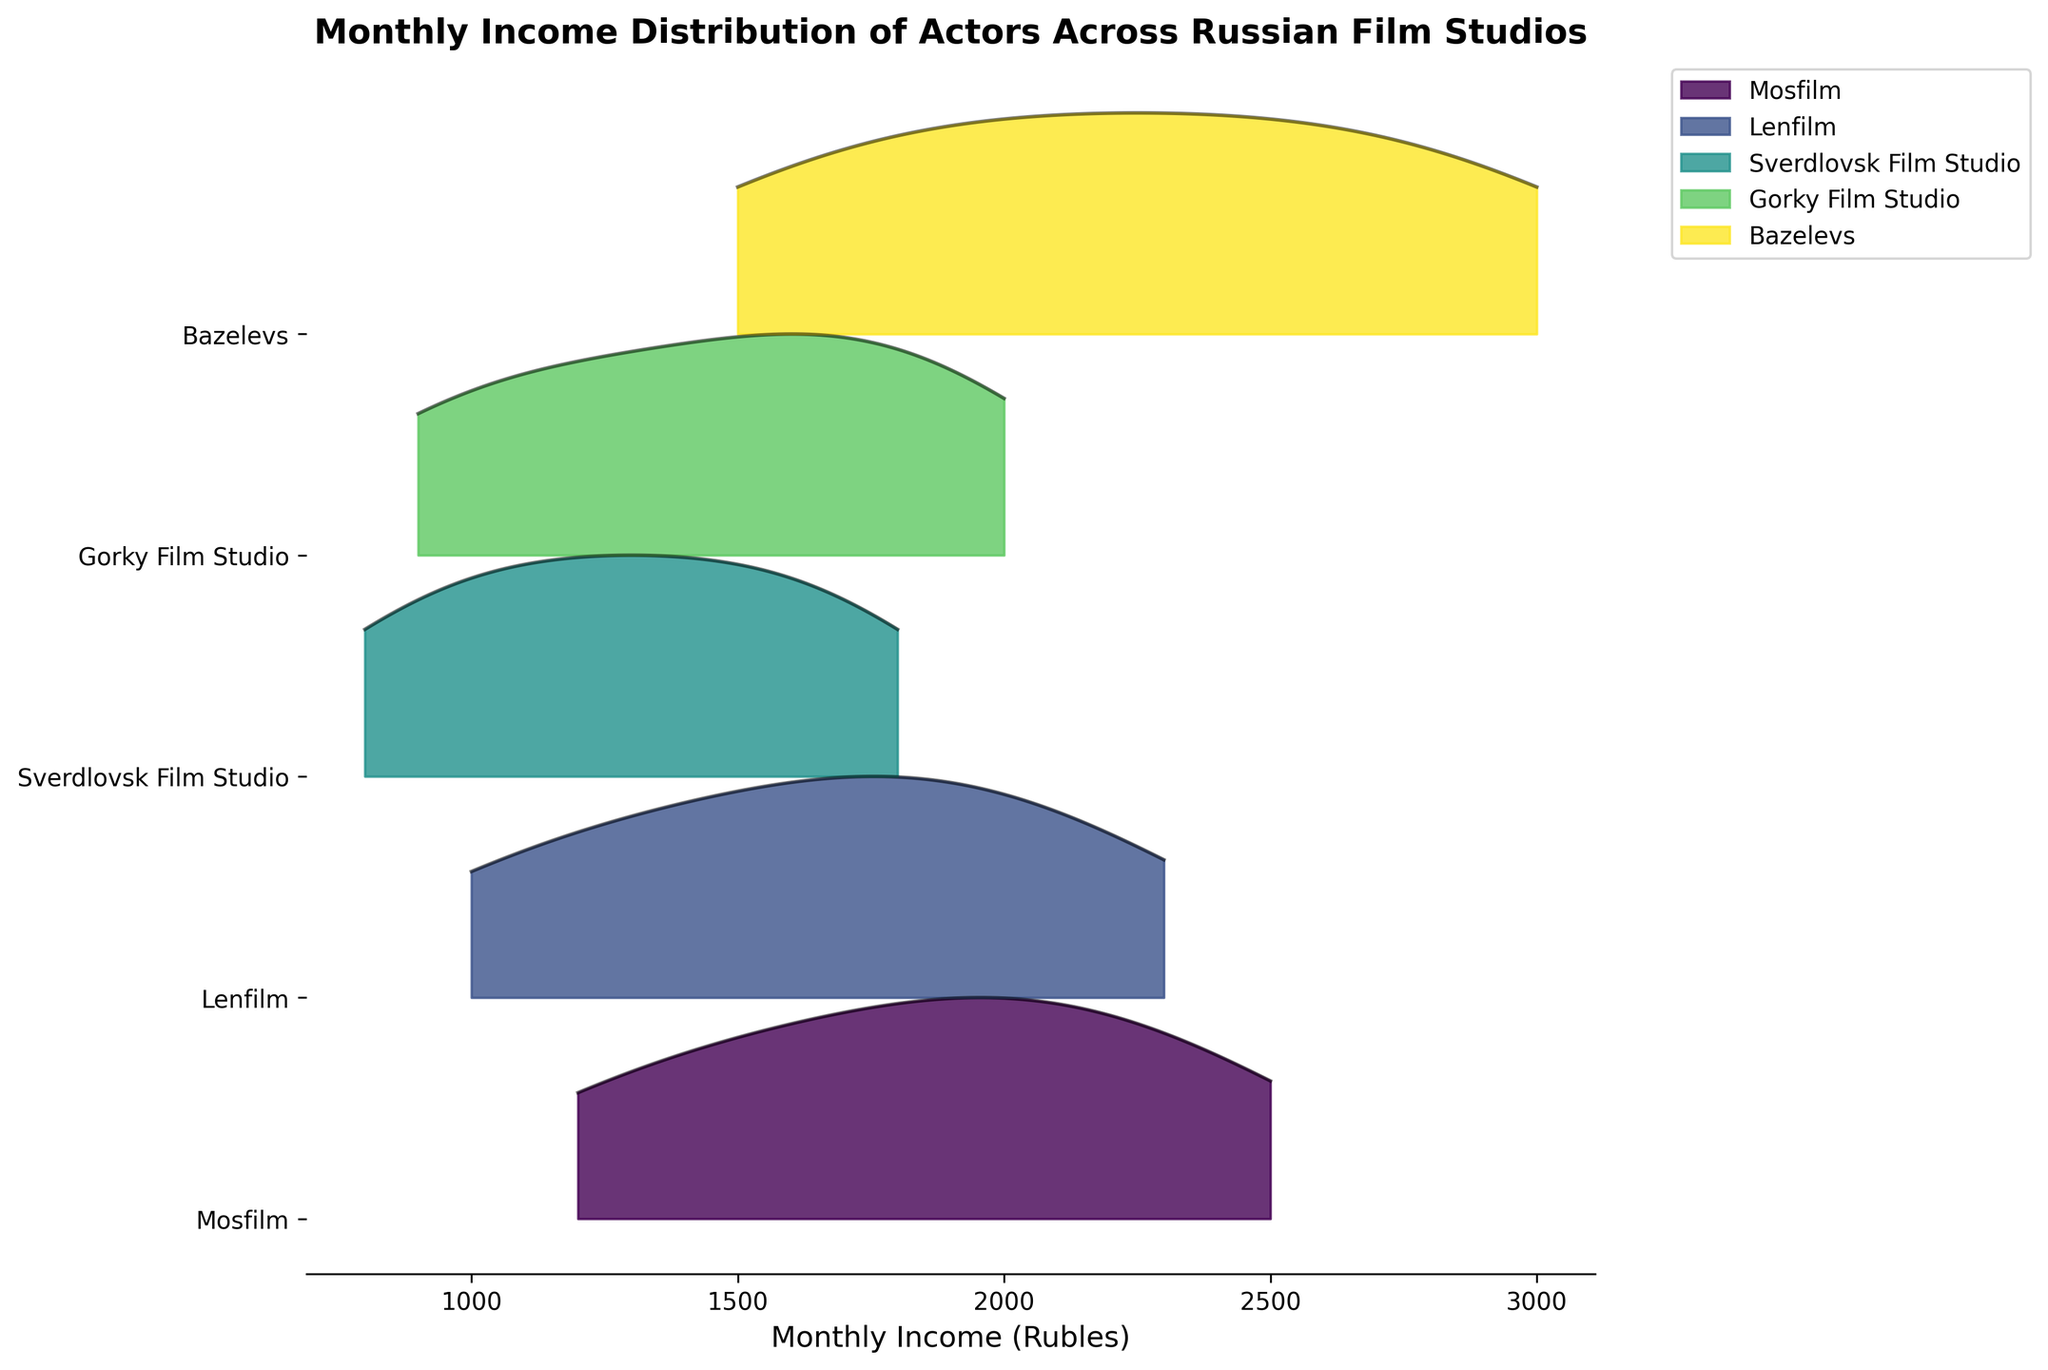What's the title of the figure? The title is typically displayed in a large font at the top of the plot. It summarises what the plot visualizes.
Answer: Monthly Income Distribution of Actors Across Russian Film Studios What's the x-axis label of the plot? The x-axis label is usually found at the bottom of the x-axis, providing contextual information about the data.
Answer: Monthly Income (Rubles) Which film studio shows the highest monthly income for actors in June? By observing the plot, locate the density peaks for each film studio in June and identify the highest peak.
Answer: Bazelevs Which studio has the smallest income range? Find the income ranges for each studio by observing the spread of the density curves along the x-axis and identify the one with the narrowest spread.
Answer: Sverdlovsk Film Studio What is the monthly income range for Mosfilm from January to June? Observe the plot to see the minimum and maximum points of Mosfilm's density curves across the months from January to June.
Answer: 1200 to 2500 Rubles How does the income distribution of Lenfilm compare to Gorky Film Studio in April? Compare the density curves of Lenfilm and Gorky Film Studio specifically for April. Note the differences or similarities in spread and peak positioning.
Answer: Lenfilm peaks lower and has a narrower spread compared to Gorky Film Studio Which studio shows the most consistent increase in monthly incomes over the months? Observe the overall trend in the density curves across months for each studio, identifying which one increases steadily without large fluctuations.
Answer: Bazelevs Do any studios have overlapping monthly income ranges? Look at the spreads of the density curves for different studios to see if there are shared x-axis income ranges, indicating overlap.
Answer: Yes Which studio has the least variation in monthly income by June? By June, identify which studio has the narrowest density spread at the peak, indicating the smallest variation.
Answer: Sverdlovsk Film Studio 